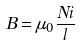Convert formula to latex. <formula><loc_0><loc_0><loc_500><loc_500>B = \mu _ { 0 } \frac { N i } { l }</formula> 